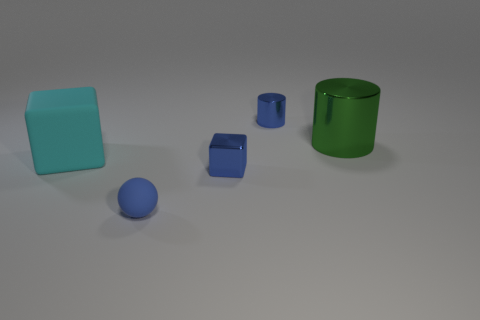What is the material of the small blue object that is on the right side of the blue matte ball and in front of the green thing?
Ensure brevity in your answer.  Metal. What number of tiny objects are in front of the cyan rubber object and to the right of the ball?
Your response must be concise. 1. What is the color of the tiny thing that is in front of the tiny metallic thing that is in front of the cyan rubber cube?
Offer a very short reply. Blue. The green object that is the same size as the cyan thing is what shape?
Provide a succinct answer. Cylinder. There is a cylinder that is the same size as the blue rubber object; what is its material?
Your answer should be very brief. Metal. Are there any small blue metallic objects in front of the metal object that is right of the tiny metallic thing behind the large cyan object?
Keep it short and to the point. Yes. There is a rubber thing right of the large rubber object; is it the same color as the small object that is behind the tiny cube?
Make the answer very short. Yes. There is a tiny cylinder that is the same color as the ball; what is it made of?
Offer a very short reply. Metal. There is a rubber ball right of the matte thing that is on the left side of the tiny matte thing in front of the big rubber object; what size is it?
Offer a terse response. Small. Is there a small sphere that has the same color as the metal cube?
Your answer should be very brief. Yes. 